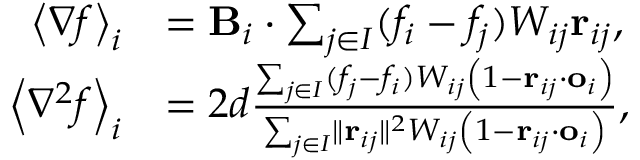<formula> <loc_0><loc_0><loc_500><loc_500>\begin{array} { r l } { \left < \nabla f \right > _ { i } } & { = B _ { i } \cdot \sum _ { j \in I } ( f _ { i } - f _ { j } ) W _ { i j } r _ { i j } , } \\ { \left < \nabla ^ { 2 } f \right > _ { i } } & { = 2 d \frac { \sum _ { j \in I } ( f _ { j } - f _ { i } ) W _ { i j } \left ( 1 - r _ { i j } \cdot o _ { i } \right ) } { \sum _ { j \in I } \| r _ { i j } \| ^ { 2 } W _ { i j } \left ( 1 - r _ { i j } \cdot o _ { i } \right ) } , } \end{array}</formula> 